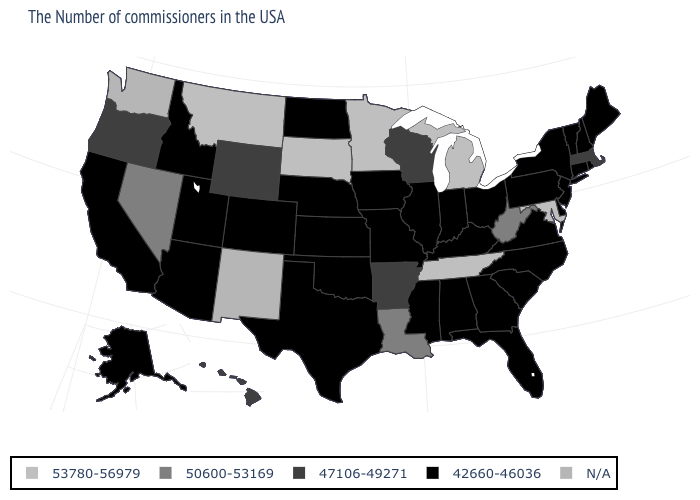Name the states that have a value in the range N/A?
Answer briefly. New Mexico, Washington. Is the legend a continuous bar?
Give a very brief answer. No. What is the highest value in the USA?
Be succinct. 53780-56979. What is the value of New Hampshire?
Give a very brief answer. 42660-46036. Among the states that border Tennessee , which have the highest value?
Short answer required. Arkansas. What is the value of Arizona?
Keep it brief. 42660-46036. Name the states that have a value in the range 42660-46036?
Write a very short answer. Maine, Rhode Island, New Hampshire, Vermont, Connecticut, New York, New Jersey, Delaware, Pennsylvania, Virginia, North Carolina, South Carolina, Ohio, Florida, Georgia, Kentucky, Indiana, Alabama, Illinois, Mississippi, Missouri, Iowa, Kansas, Nebraska, Oklahoma, Texas, North Dakota, Colorado, Utah, Arizona, Idaho, California, Alaska. Name the states that have a value in the range 53780-56979?
Answer briefly. Maryland, Michigan, Tennessee, Minnesota, South Dakota, Montana. Name the states that have a value in the range 42660-46036?
Concise answer only. Maine, Rhode Island, New Hampshire, Vermont, Connecticut, New York, New Jersey, Delaware, Pennsylvania, Virginia, North Carolina, South Carolina, Ohio, Florida, Georgia, Kentucky, Indiana, Alabama, Illinois, Mississippi, Missouri, Iowa, Kansas, Nebraska, Oklahoma, Texas, North Dakota, Colorado, Utah, Arizona, Idaho, California, Alaska. Does Kentucky have the lowest value in the USA?
Give a very brief answer. Yes. What is the value of Oklahoma?
Quick response, please. 42660-46036. What is the value of Rhode Island?
Quick response, please. 42660-46036. Name the states that have a value in the range N/A?
Keep it brief. New Mexico, Washington. What is the value of Wisconsin?
Short answer required. 47106-49271. 